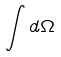<formula> <loc_0><loc_0><loc_500><loc_500>\int d \Omega</formula> 